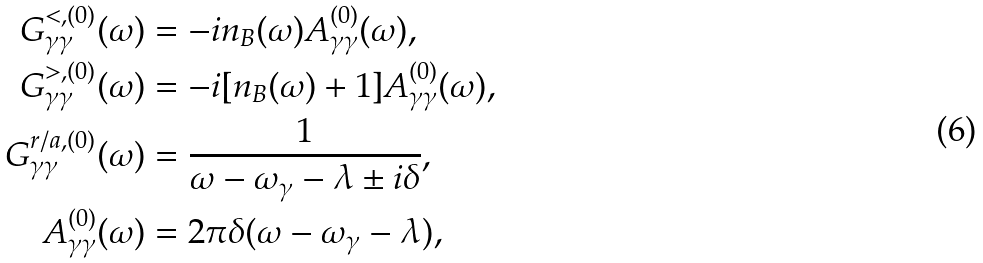<formula> <loc_0><loc_0><loc_500><loc_500>G _ { \gamma \gamma } ^ { < , ( 0 ) } ( \omega ) & = - i n _ { B } ( \omega ) A _ { \gamma \gamma } ^ { ( 0 ) } ( \omega ) , \\ G _ { \gamma \gamma } ^ { > , ( 0 ) } ( \omega ) & = - i [ n _ { B } ( \omega ) + 1 ] A _ { \gamma \gamma } ^ { ( 0 ) } ( \omega ) , \\ G _ { \gamma \gamma } ^ { r / a , ( 0 ) } ( \omega ) & = \frac { 1 } { \omega - \omega _ { \gamma } - \lambda \pm i \delta } , \\ A _ { \gamma \gamma } ^ { ( 0 ) } ( \omega ) & = 2 \pi \delta ( \omega - \omega _ { \gamma } - \lambda ) ,</formula> 